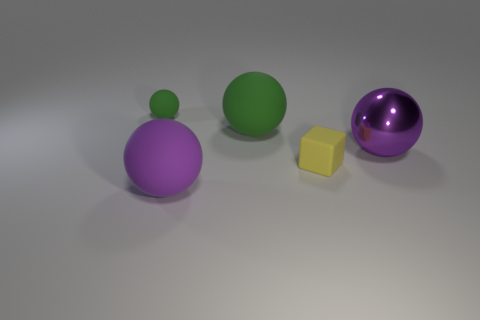Subtract all small spheres. How many spheres are left? 3 Subtract 1 cubes. How many cubes are left? 0 Add 2 tiny cylinders. How many objects exist? 7 Subtract all balls. How many objects are left? 1 Subtract all gray cubes. Subtract all red cylinders. How many cubes are left? 1 Subtract all yellow cylinders. How many brown cubes are left? 0 Subtract all large purple metal objects. Subtract all large purple balls. How many objects are left? 2 Add 1 small matte spheres. How many small matte spheres are left? 2 Add 4 small yellow objects. How many small yellow objects exist? 5 Subtract 0 red blocks. How many objects are left? 5 